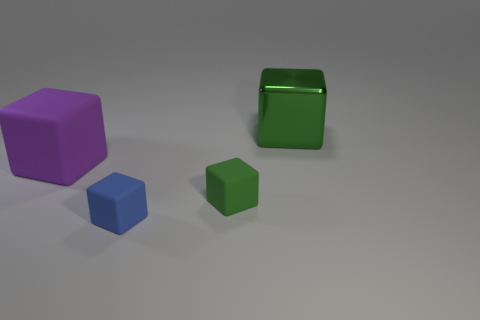Subtract all large purple blocks. How many blocks are left? 3 Add 4 small blue blocks. How many objects exist? 8 Subtract all green balls. How many green cubes are left? 2 Subtract all purple blocks. How many blocks are left? 3 Subtract 1 cubes. How many cubes are left? 3 Subtract all blue blocks. Subtract all purple cylinders. How many blocks are left? 3 Subtract all small blue objects. Subtract all rubber objects. How many objects are left? 0 Add 4 large purple blocks. How many large purple blocks are left? 5 Add 3 tiny red metal cubes. How many tiny red metal cubes exist? 3 Subtract 0 gray cylinders. How many objects are left? 4 